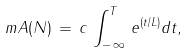Convert formula to latex. <formula><loc_0><loc_0><loc_500><loc_500>\ m { A ( N ) \, = \, c \, \int _ { - \, \infty } ^ { T } \, e ^ { ( t / L ) } d t } ,</formula> 